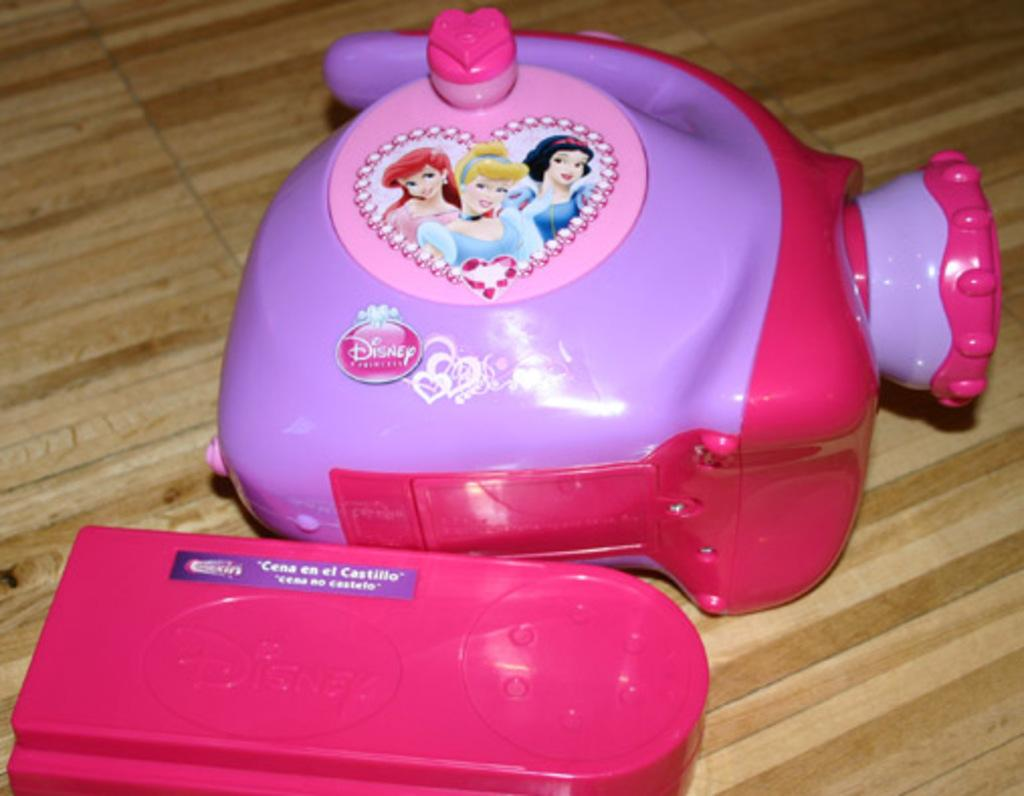How many toys can be seen in the image? There are two toys in the image. What is the surface on which the toys are placed? The toys are on a wooden surface. What type of jeans is the fifth toy wearing in the image? There are only two toys present in the image, and neither of them is wearing jeans. 